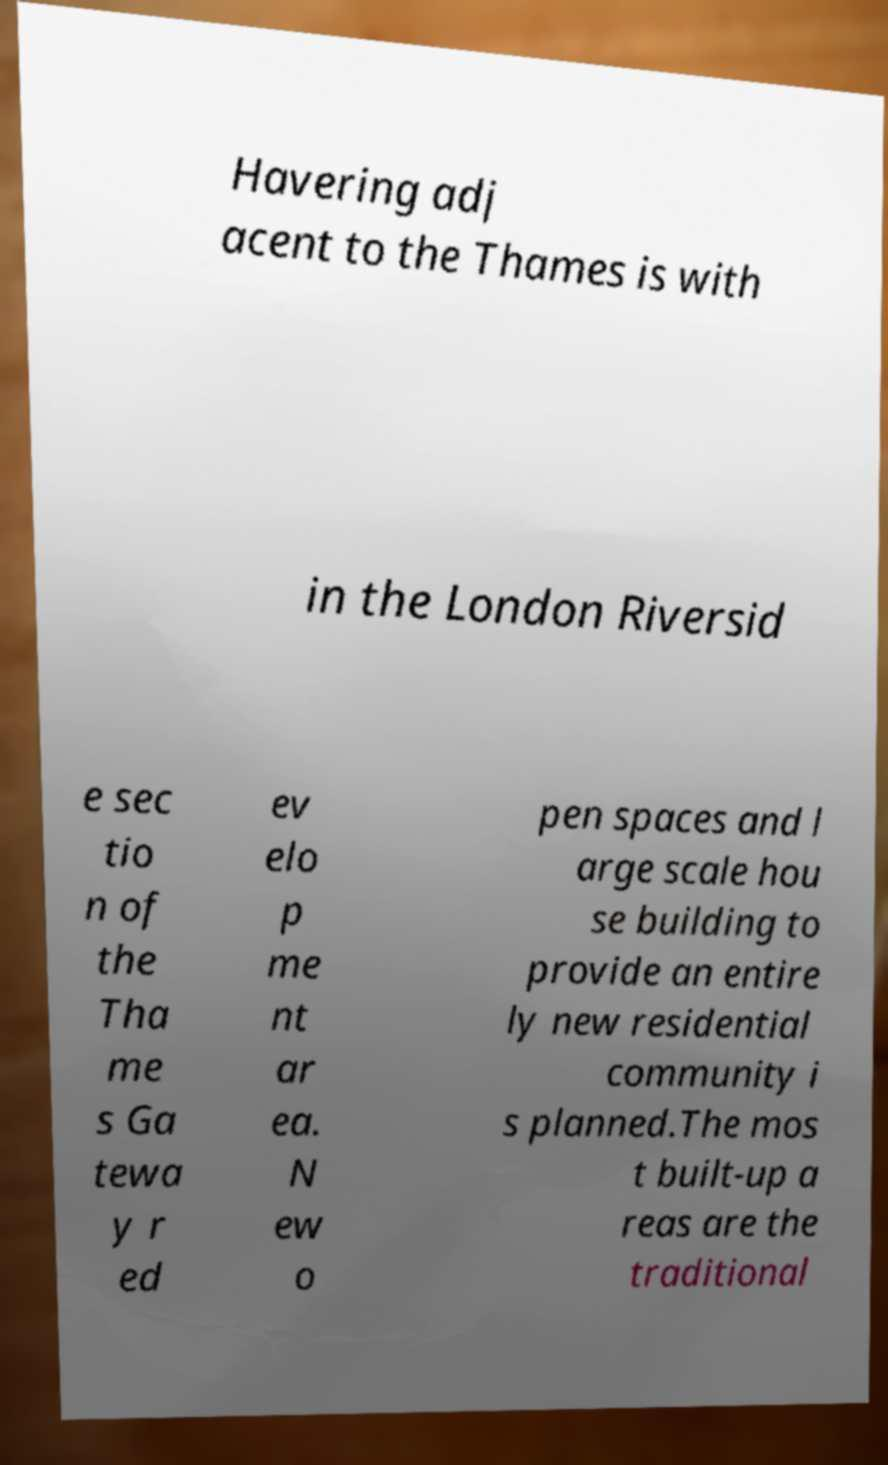There's text embedded in this image that I need extracted. Can you transcribe it verbatim? Havering adj acent to the Thames is with in the London Riversid e sec tio n of the Tha me s Ga tewa y r ed ev elo p me nt ar ea. N ew o pen spaces and l arge scale hou se building to provide an entire ly new residential community i s planned.The mos t built-up a reas are the traditional 